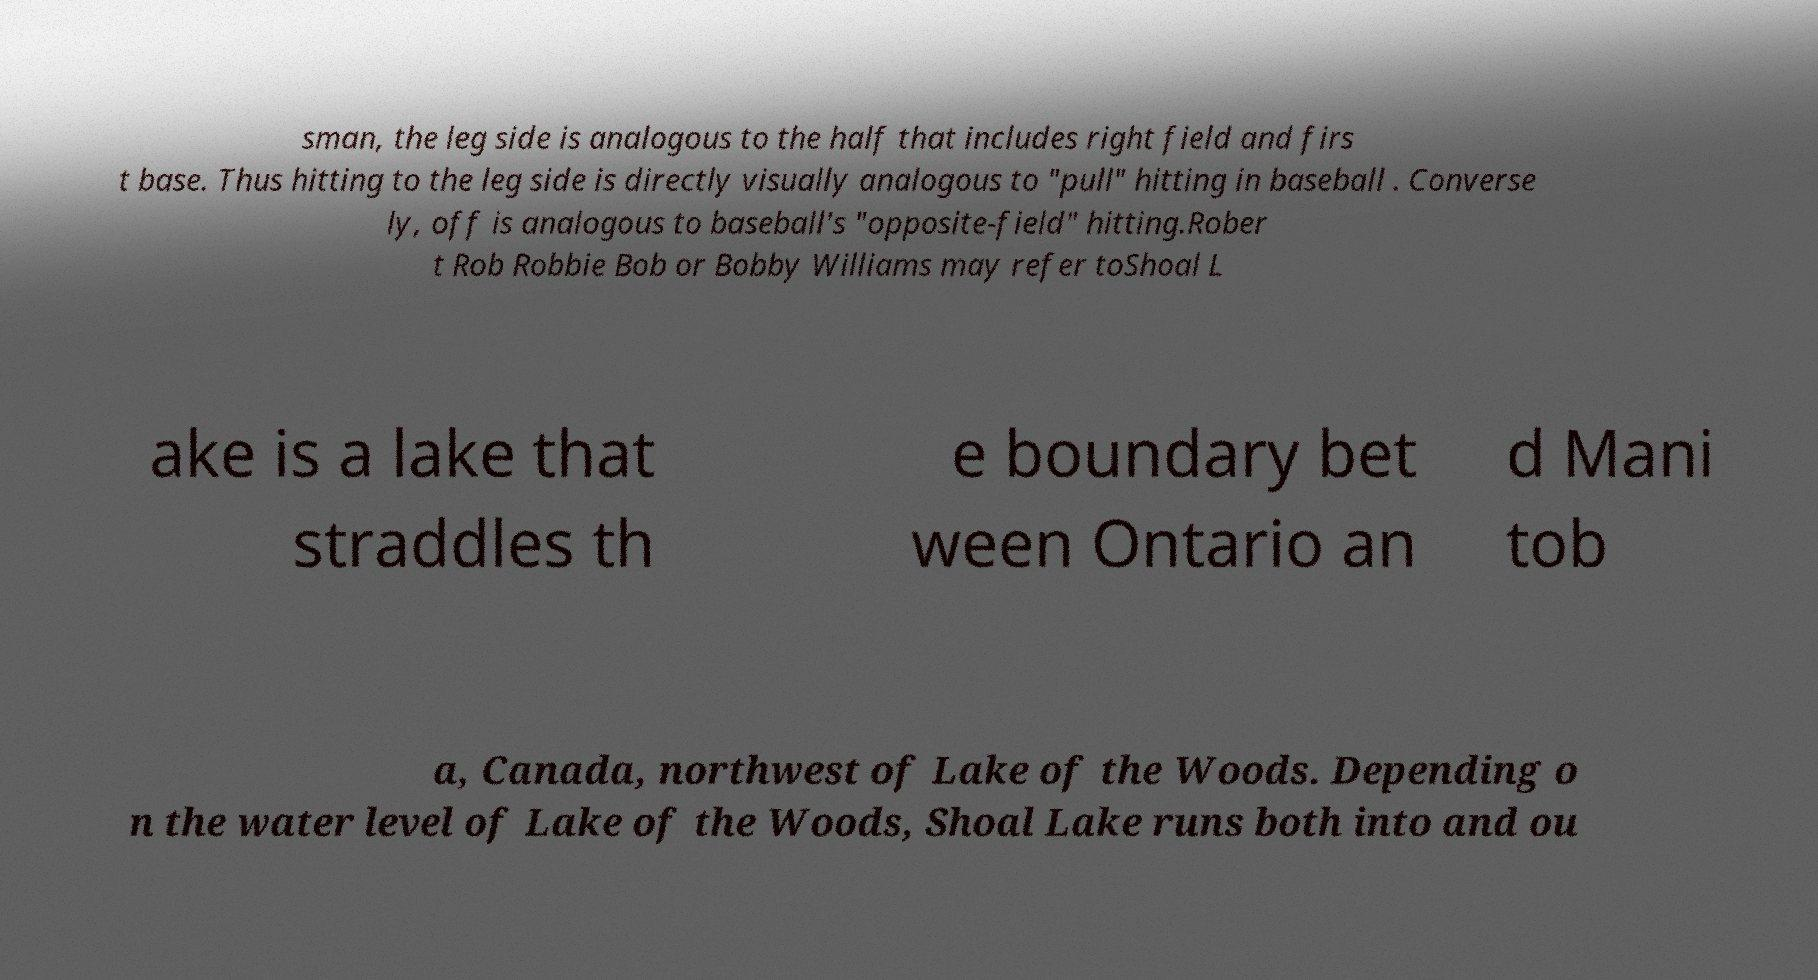For documentation purposes, I need the text within this image transcribed. Could you provide that? sman, the leg side is analogous to the half that includes right field and firs t base. Thus hitting to the leg side is directly visually analogous to "pull" hitting in baseball . Converse ly, off is analogous to baseball's "opposite-field" hitting.Rober t Rob Robbie Bob or Bobby Williams may refer toShoal L ake is a lake that straddles th e boundary bet ween Ontario an d Mani tob a, Canada, northwest of Lake of the Woods. Depending o n the water level of Lake of the Woods, Shoal Lake runs both into and ou 